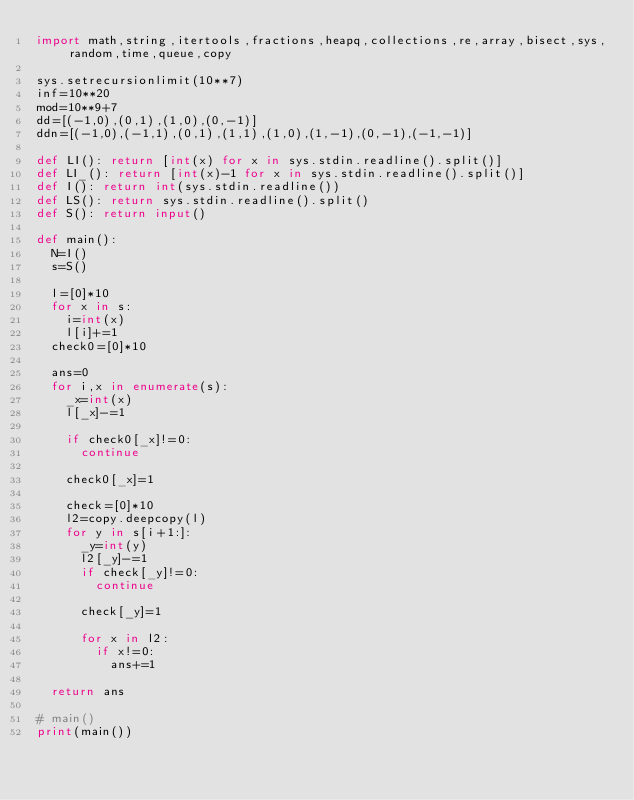Convert code to text. <code><loc_0><loc_0><loc_500><loc_500><_Python_>import math,string,itertools,fractions,heapq,collections,re,array,bisect,sys,random,time,queue,copy

sys.setrecursionlimit(10**7)
inf=10**20
mod=10**9+7
dd=[(-1,0),(0,1),(1,0),(0,-1)]
ddn=[(-1,0),(-1,1),(0,1),(1,1),(1,0),(1,-1),(0,-1),(-1,-1)]

def LI(): return [int(x) for x in sys.stdin.readline().split()]
def LI_(): return [int(x)-1 for x in sys.stdin.readline().split()]
def I(): return int(sys.stdin.readline())
def LS(): return sys.stdin.readline().split()
def S(): return input()

def main():
  N=I()
  s=S()

  l=[0]*10
  for x in s:
    i=int(x)
    l[i]+=1
  check0=[0]*10

  ans=0
  for i,x in enumerate(s):
    _x=int(x)
    l[_x]-=1

    if check0[_x]!=0:
      continue

    check0[_x]=1

    check=[0]*10
    l2=copy.deepcopy(l)
    for y in s[i+1:]:
      _y=int(y)
      l2[_y]-=1
      if check[_y]!=0:
        continue

      check[_y]=1

      for x in l2:
        if x!=0:
          ans+=1

  return ans

# main()
print(main())
</code> 